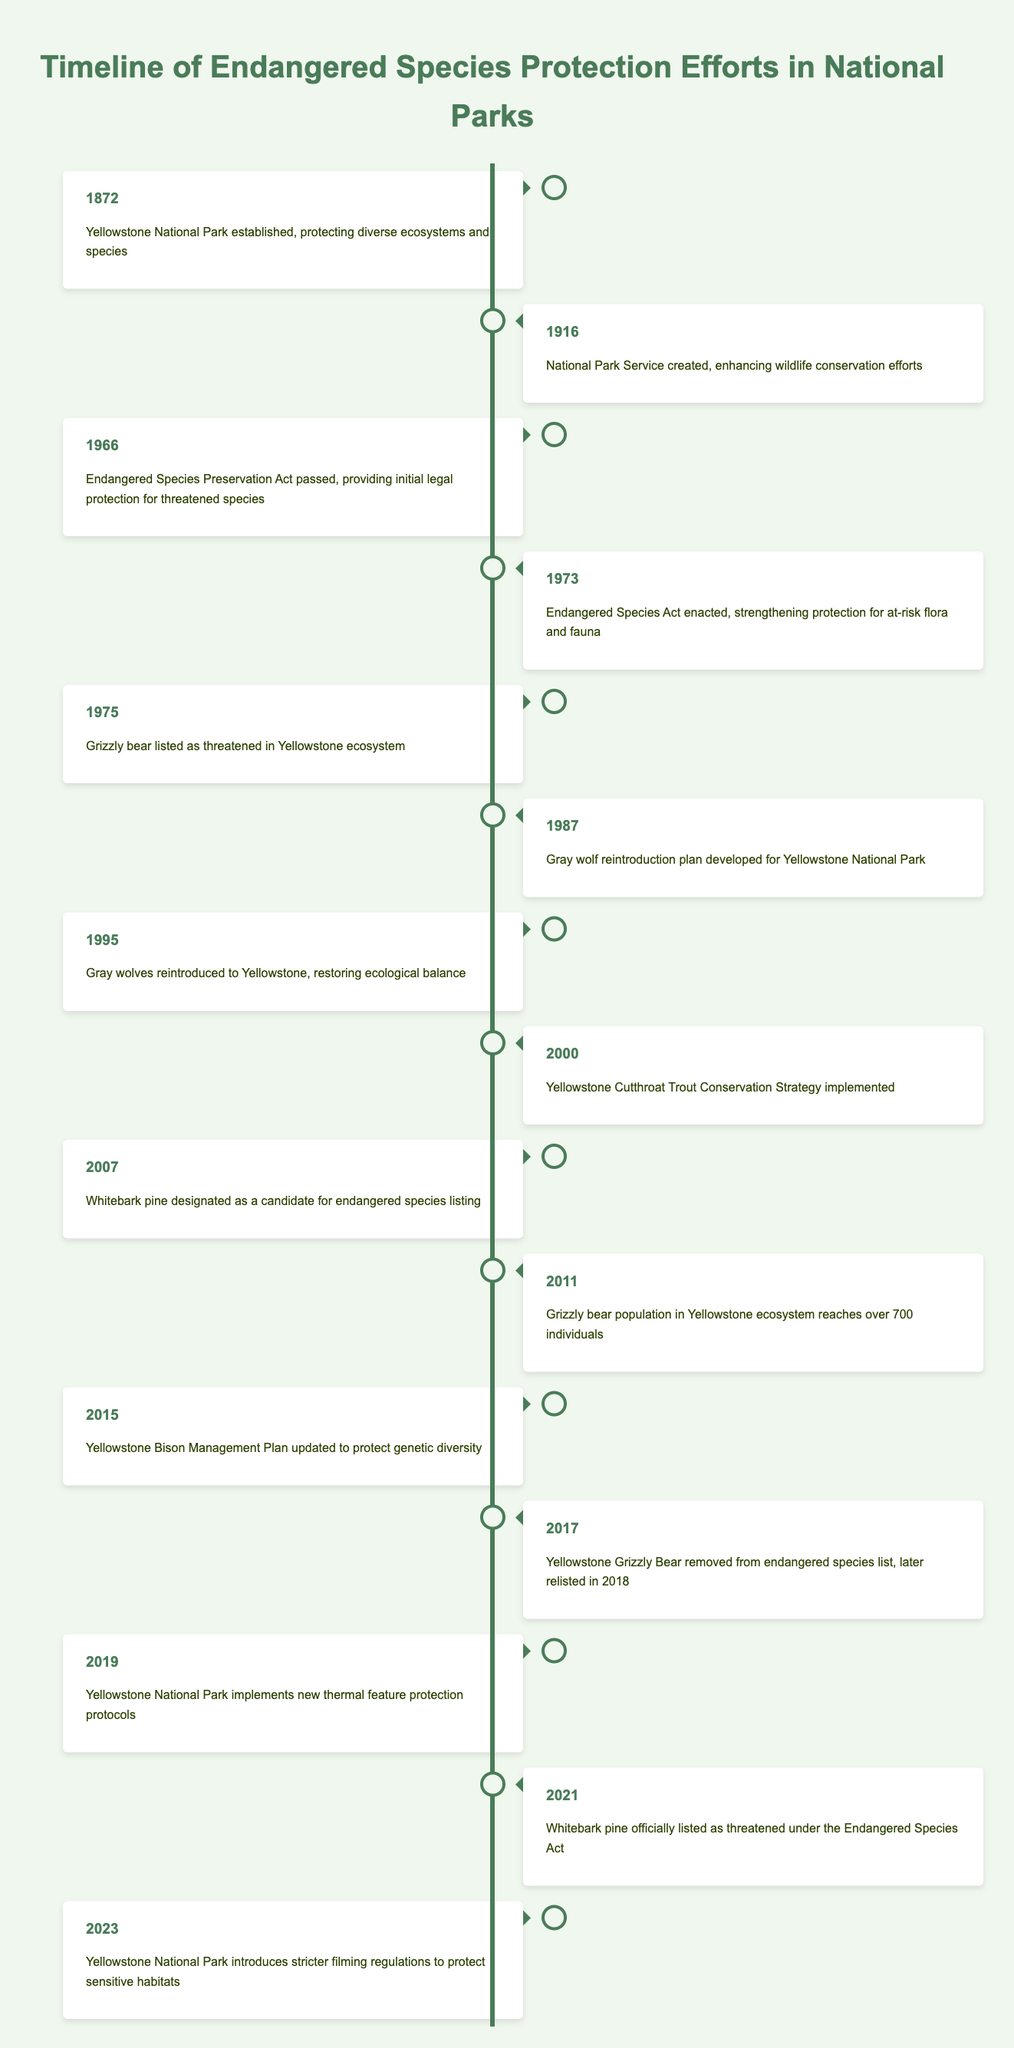What year was the Endangered Species Act enacted? From the table, we see that the Endangered Species Act was enacted in 1973. This information is directly available in the row for that year, which states "Endangered Species Act enacted, strengthening protection for at-risk flora and fauna."
Answer: 1973 Which species was listed as threatened in the Yellowstone ecosystem in 1975? According to the table, in 1975, the Grizzly bear was listed as threatened in the Yellowstone ecosystem, as indicated in the relevant entry for that year.
Answer: Grizzly bear How many years passed from the establishment of Yellowstone National Park to the listing of the Grizzly bear as threatened? The establishment of Yellowstone National Park occurred in 1872 and the Grizzly bear was listed as threatened in 1975. The difference in years is calculated as 1975 - 1872 = 103 years.
Answer: 103 Was the Whitebark pine designated as a candidate for endangered species listing before it was officially listed as threatened? Yes, based on the table, Whitebark pine was designated as a candidate for endangered species listing in 2007 and was officially listed as threatened in 2021. This indicates that there was a period during which it was considered a candidate before the official listing.
Answer: Yes What significant ecological restoration event took place in 1995? In 1995, gray wolves were reintroduced to Yellowstone, which is noted in the table. This is a major ecological restoration action aimed at restoring the ecological balance in the park.
Answer: Gray wolves reintroduced What is the sequence of events related to the Grizzly bear from 1975 to 2018? From the table, the sequence is: In 1975, the Grizzly bear was listed as threatened. In 2017, it was removed from the endangered species list, and then it was later relisted in 2018. This shows the bear's changing status in terms of protection under the law over those years.
Answer: Listed in 1975, removed in 2017, relisted in 2018 How many significant events related to endangered species occurred in the 2000s according to the table? The table shows three significant events related to endangered species in the 2000s: in 2000 (Yellowstone Cutthroat Trout Conservation Strategy), 2007 (Whitebark pine designated as a candidate), and in 2011 (Grizzly bear population growth). Adding these gives us a total of 3 events.
Answer: 3 Did the Yellowstone National Park introduce stricter filming regulations to protect sensitive habitats before or after the Grizzly bear was relisted in 2018? According to the table, stricter filming regulations were introduced in 2023, which is after the Grizzly bear was relisted in 2018. This indicates the ongoing efforts to protect wildlife in response to changing conservation needs.
Answer: After What year did the Gray wolf restoration plan get developed? From the table, the gray wolf reintroduction plan was developed in 1987. This is specifically mentioned in the event description for that year, highlighting a key step in conservation efforts for this species.
Answer: 1987 